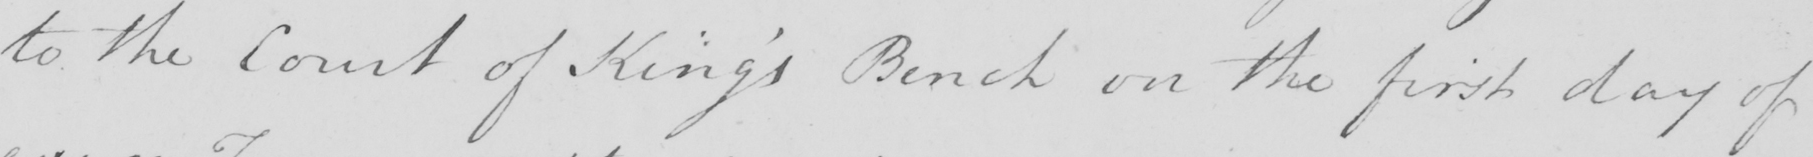Transcribe the text shown in this historical manuscript line. to the Court of King ' s Bench on the first day of 